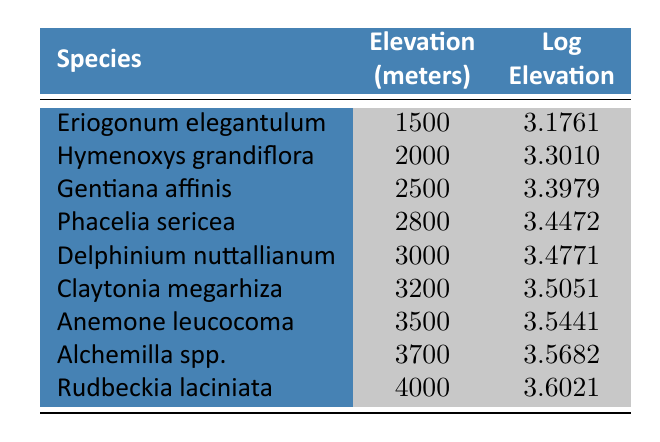What is the elevation in meters of Eriogonum elegantulum? The table lists Eriogonum elegantulum and shows its corresponding elevation as 1500 meters in the second column.
Answer: 1500 How many rare flora species are found above 3000 meters elevation? By examining the table, the species with elevations above 3000 meters are Delphinium nuttallianum (3000), Claytonia megarhiza (3200), Anemone leucocoma (3500), Alchemilla spp. (3700), and Rudbeckia laciniata (4000), which totals 5 species.
Answer: 5 What is the difference in elevation (in meters) between the highest and lowest species? The highest species is Rudbeckia laciniata at 4000 meters and the lowest is Eriogonum elegantulum at 1500 meters. The difference is calculated as 4000 - 1500 = 2500 meters.
Answer: 2500 Is the log elevation of Gentiana affinis greater than that of Claytonia megarhiza? The table shows that Gentiana affinis has a log elevation of 3.3979 and Claytonia megarhiza has a log elevation of 3.5051. Since 3.3979 is less than 3.5051, the statement is false.
Answer: No What is the average log elevation of the species between 2500 and 3500 meters? The relevant species are Gentiana affinis (3.3979), Phacelia sericea (3.4472), Delphinium nuttallianum (3.4771), Claytonia megarhiza (3.5051), and Anemone leucocoma (3.5441). To find the average, sum the log elevations (3.3979 + 3.4472 + 3.4771 + 3.5051 + 3.5441 = 17.3714) and divide by the number of species (5). The average log elevation is 17.3714/5 = 3.4743.
Answer: 3.4743 